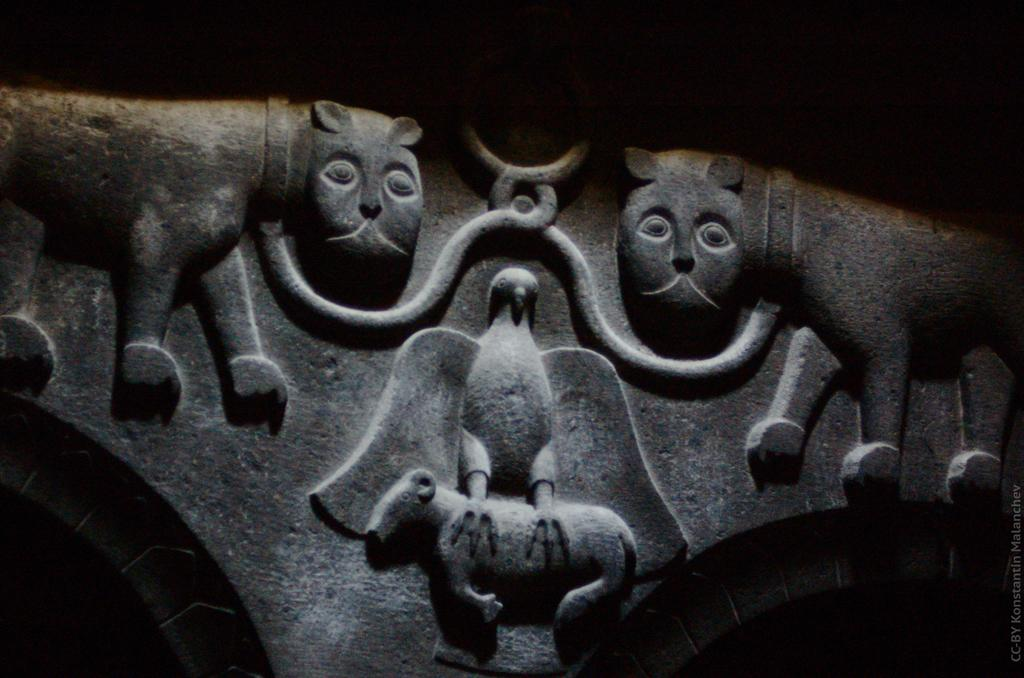What is the color scheme of the image? The image is black and white. What can be seen on the wall in the image? There is a sculpture on the wall in the image. Where is the waste bin located in the image? There is no waste bin present in the image. Can you describe the uncle in the image? There is no uncle present in the image. 